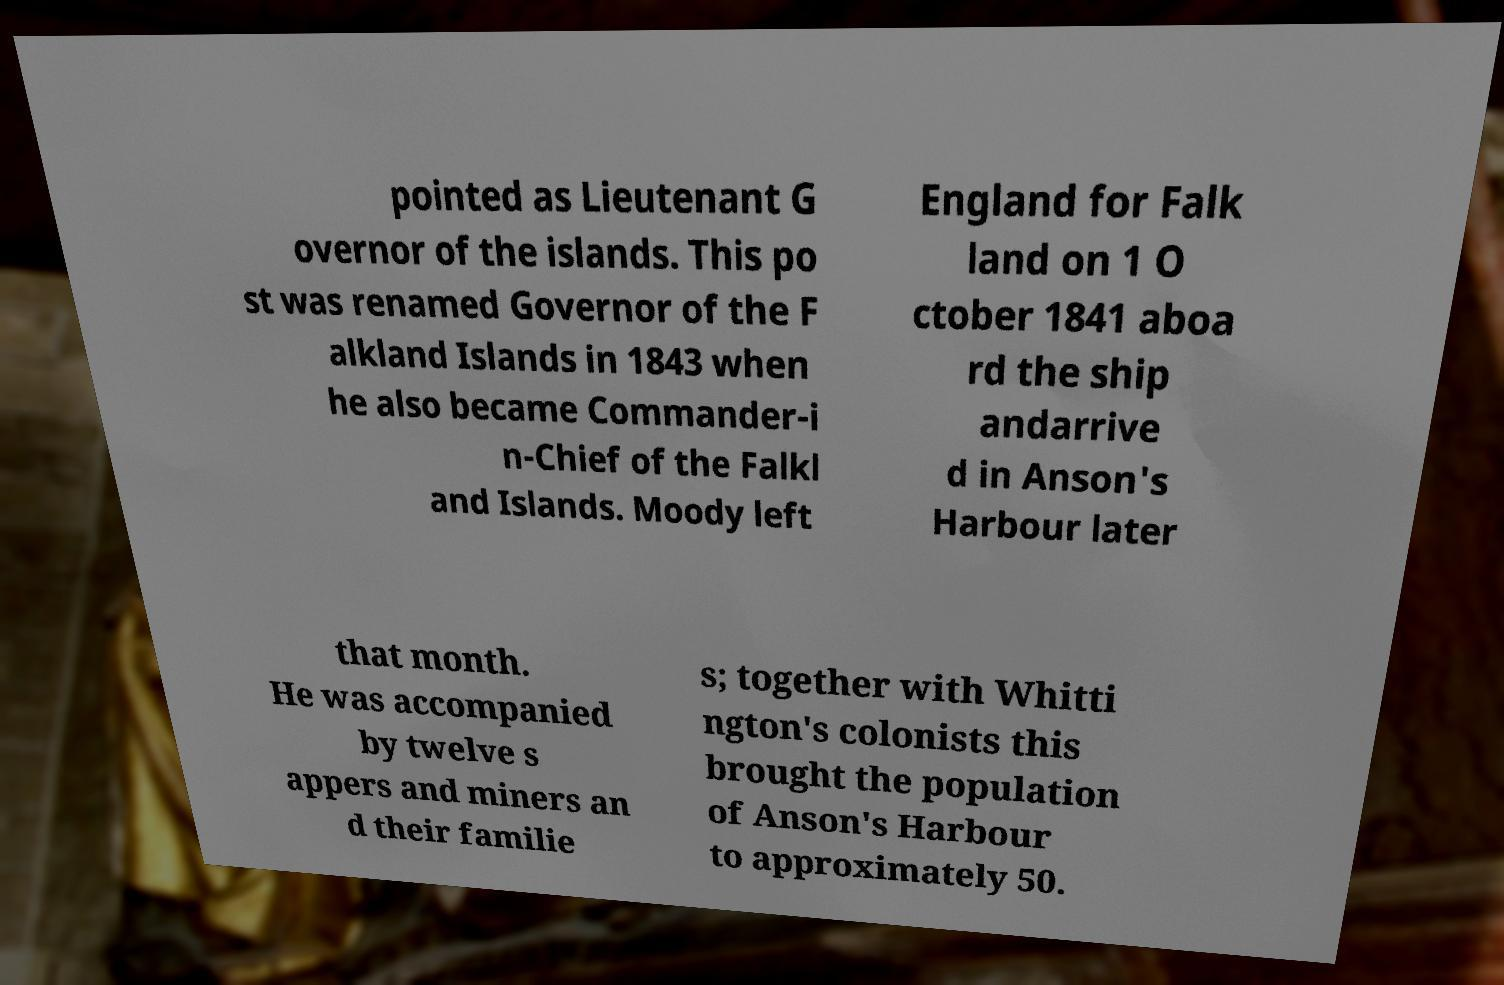I need the written content from this picture converted into text. Can you do that? pointed as Lieutenant G overnor of the islands. This po st was renamed Governor of the F alkland Islands in 1843 when he also became Commander-i n-Chief of the Falkl and Islands. Moody left England for Falk land on 1 O ctober 1841 aboa rd the ship andarrive d in Anson's Harbour later that month. He was accompanied by twelve s appers and miners an d their familie s; together with Whitti ngton's colonists this brought the population of Anson's Harbour to approximately 50. 